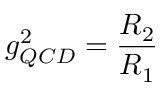<formula> <loc_0><loc_0><loc_500><loc_500>g _ { Q C D } ^ { 2 } = \frac { R _ { 2 } } { R _ { 1 } }</formula> 